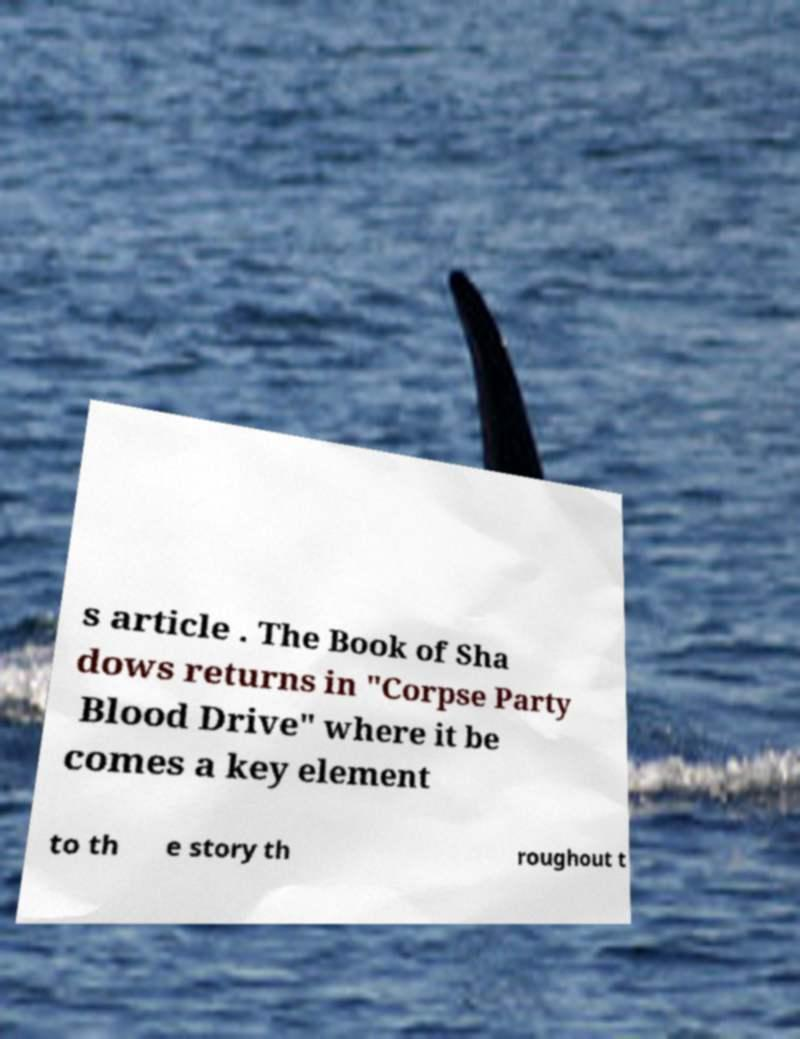For documentation purposes, I need the text within this image transcribed. Could you provide that? s article . The Book of Sha dows returns in "Corpse Party Blood Drive" where it be comes a key element to th e story th roughout t 